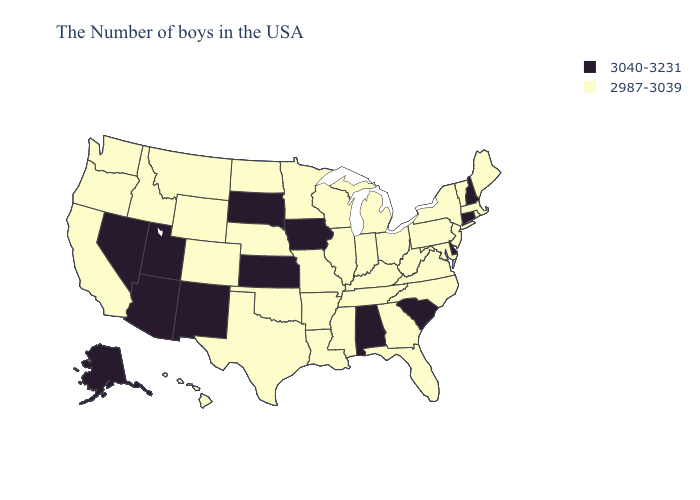Name the states that have a value in the range 2987-3039?
Give a very brief answer. Maine, Massachusetts, Rhode Island, Vermont, New York, New Jersey, Maryland, Pennsylvania, Virginia, North Carolina, West Virginia, Ohio, Florida, Georgia, Michigan, Kentucky, Indiana, Tennessee, Wisconsin, Illinois, Mississippi, Louisiana, Missouri, Arkansas, Minnesota, Nebraska, Oklahoma, Texas, North Dakota, Wyoming, Colorado, Montana, Idaho, California, Washington, Oregon, Hawaii. Which states have the highest value in the USA?
Concise answer only. New Hampshire, Connecticut, Delaware, South Carolina, Alabama, Iowa, Kansas, South Dakota, New Mexico, Utah, Arizona, Nevada, Alaska. Among the states that border South Dakota , does Wyoming have the highest value?
Keep it brief. No. What is the lowest value in the MidWest?
Keep it brief. 2987-3039. Does the map have missing data?
Be succinct. No. Among the states that border California , which have the highest value?
Keep it brief. Arizona, Nevada. Which states have the lowest value in the West?
Short answer required. Wyoming, Colorado, Montana, Idaho, California, Washington, Oregon, Hawaii. Does Indiana have the lowest value in the MidWest?
Give a very brief answer. Yes. Among the states that border Arkansas , which have the highest value?
Answer briefly. Tennessee, Mississippi, Louisiana, Missouri, Oklahoma, Texas. What is the lowest value in the South?
Short answer required. 2987-3039. Among the states that border Illinois , does Indiana have the highest value?
Answer briefly. No. What is the value of Mississippi?
Answer briefly. 2987-3039. Name the states that have a value in the range 2987-3039?
Keep it brief. Maine, Massachusetts, Rhode Island, Vermont, New York, New Jersey, Maryland, Pennsylvania, Virginia, North Carolina, West Virginia, Ohio, Florida, Georgia, Michigan, Kentucky, Indiana, Tennessee, Wisconsin, Illinois, Mississippi, Louisiana, Missouri, Arkansas, Minnesota, Nebraska, Oklahoma, Texas, North Dakota, Wyoming, Colorado, Montana, Idaho, California, Washington, Oregon, Hawaii. Does Nebraska have the highest value in the USA?
Write a very short answer. No. Among the states that border New Jersey , which have the highest value?
Quick response, please. Delaware. 